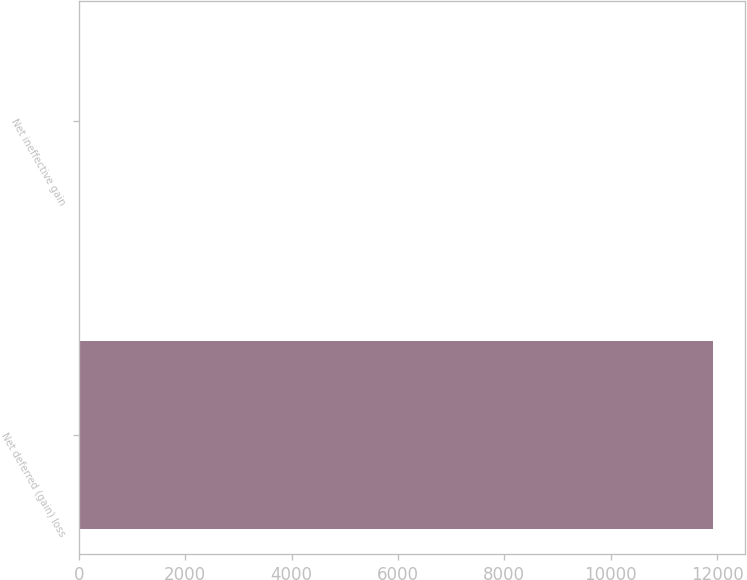<chart> <loc_0><loc_0><loc_500><loc_500><bar_chart><fcel>Net deferred (gain) loss<fcel>Net ineffective gain<nl><fcel>11922<fcel>15<nl></chart> 